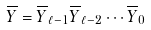<formula> <loc_0><loc_0><loc_500><loc_500>\overline { Y } = \overline { Y } _ { \ell - 1 } \overline { Y } _ { \ell - 2 } \cdots \overline { Y } _ { 0 }</formula> 